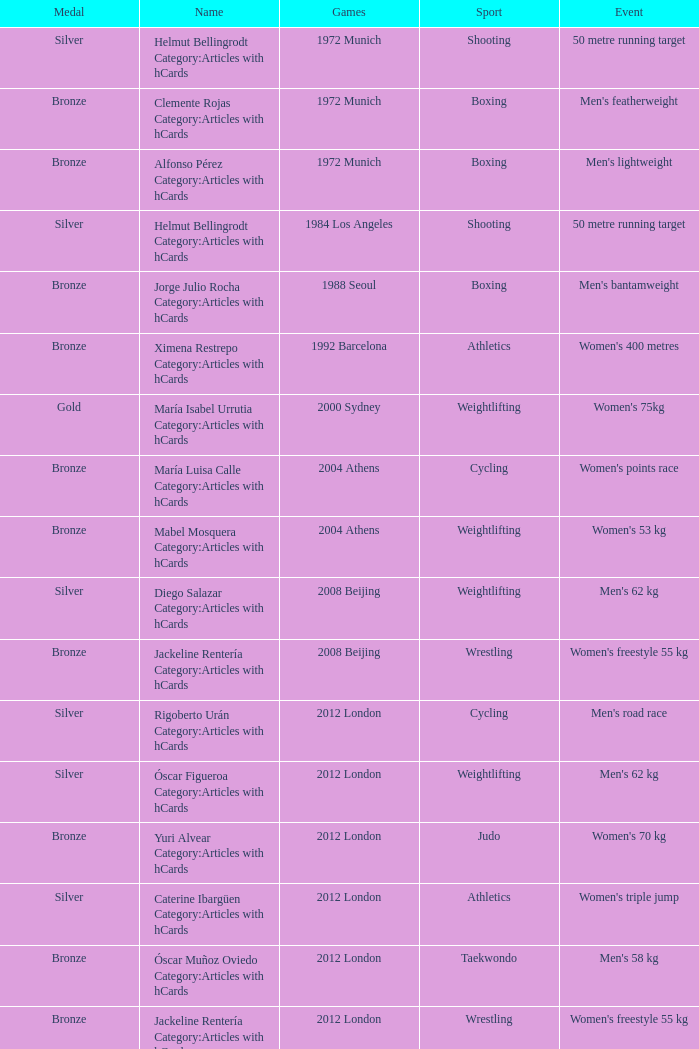Which wrestling event was at the 2008 Beijing games? Women's freestyle 55 kg. 